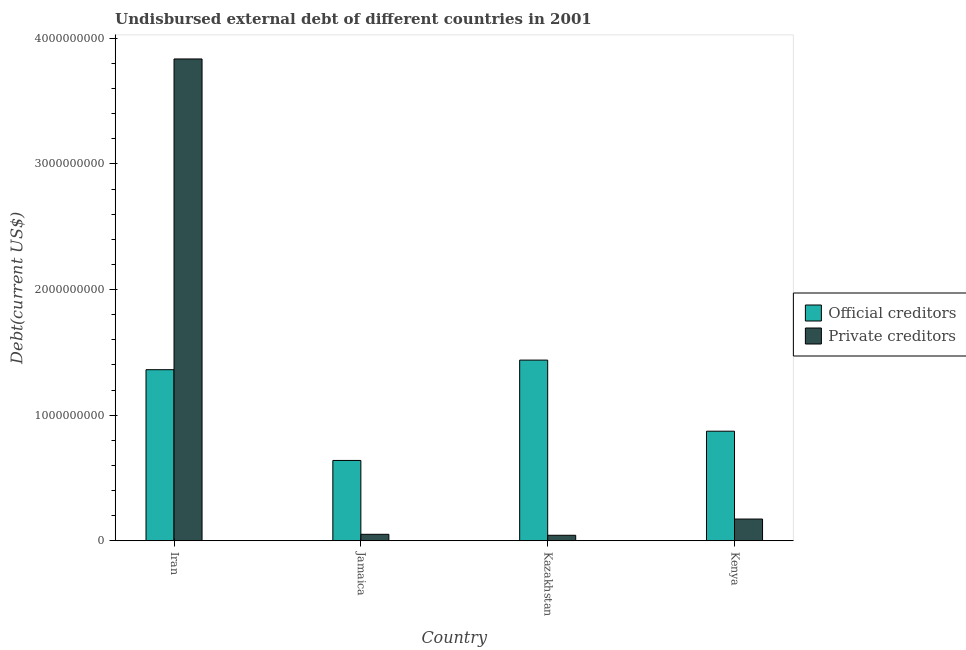How many bars are there on the 4th tick from the left?
Provide a short and direct response. 2. What is the label of the 3rd group of bars from the left?
Your response must be concise. Kazakhstan. In how many cases, is the number of bars for a given country not equal to the number of legend labels?
Offer a terse response. 0. What is the undisbursed external debt of official creditors in Kazakhstan?
Offer a very short reply. 1.44e+09. Across all countries, what is the maximum undisbursed external debt of private creditors?
Offer a very short reply. 3.84e+09. Across all countries, what is the minimum undisbursed external debt of official creditors?
Make the answer very short. 6.39e+08. In which country was the undisbursed external debt of private creditors maximum?
Give a very brief answer. Iran. In which country was the undisbursed external debt of official creditors minimum?
Offer a terse response. Jamaica. What is the total undisbursed external debt of private creditors in the graph?
Give a very brief answer. 4.10e+09. What is the difference between the undisbursed external debt of official creditors in Jamaica and that in Kenya?
Offer a very short reply. -2.33e+08. What is the difference between the undisbursed external debt of official creditors in Kazakhstan and the undisbursed external debt of private creditors in Jamaica?
Your answer should be compact. 1.39e+09. What is the average undisbursed external debt of official creditors per country?
Make the answer very short. 1.08e+09. What is the difference between the undisbursed external debt of private creditors and undisbursed external debt of official creditors in Jamaica?
Your answer should be compact. -5.88e+08. In how many countries, is the undisbursed external debt of private creditors greater than 1800000000 US$?
Your answer should be very brief. 1. What is the ratio of the undisbursed external debt of official creditors in Jamaica to that in Kazakhstan?
Ensure brevity in your answer.  0.44. Is the undisbursed external debt of private creditors in Iran less than that in Kenya?
Your answer should be compact. No. What is the difference between the highest and the second highest undisbursed external debt of private creditors?
Offer a very short reply. 3.66e+09. What is the difference between the highest and the lowest undisbursed external debt of official creditors?
Offer a terse response. 7.99e+08. In how many countries, is the undisbursed external debt of private creditors greater than the average undisbursed external debt of private creditors taken over all countries?
Offer a very short reply. 1. What does the 1st bar from the left in Kazakhstan represents?
Provide a short and direct response. Official creditors. What does the 2nd bar from the right in Jamaica represents?
Your response must be concise. Official creditors. Are all the bars in the graph horizontal?
Provide a succinct answer. No. Are the values on the major ticks of Y-axis written in scientific E-notation?
Your answer should be very brief. No. Does the graph contain any zero values?
Ensure brevity in your answer.  No. How many legend labels are there?
Your answer should be compact. 2. How are the legend labels stacked?
Your answer should be very brief. Vertical. What is the title of the graph?
Your answer should be very brief. Undisbursed external debt of different countries in 2001. Does "Commercial service imports" appear as one of the legend labels in the graph?
Your answer should be very brief. No. What is the label or title of the Y-axis?
Your answer should be compact. Debt(current US$). What is the Debt(current US$) in Official creditors in Iran?
Your answer should be very brief. 1.36e+09. What is the Debt(current US$) in Private creditors in Iran?
Offer a very short reply. 3.84e+09. What is the Debt(current US$) in Official creditors in Jamaica?
Your answer should be very brief. 6.39e+08. What is the Debt(current US$) in Private creditors in Jamaica?
Provide a short and direct response. 5.11e+07. What is the Debt(current US$) in Official creditors in Kazakhstan?
Provide a short and direct response. 1.44e+09. What is the Debt(current US$) in Private creditors in Kazakhstan?
Make the answer very short. 4.34e+07. What is the Debt(current US$) of Official creditors in Kenya?
Give a very brief answer. 8.72e+08. What is the Debt(current US$) of Private creditors in Kenya?
Your answer should be compact. 1.73e+08. Across all countries, what is the maximum Debt(current US$) of Official creditors?
Offer a very short reply. 1.44e+09. Across all countries, what is the maximum Debt(current US$) in Private creditors?
Keep it short and to the point. 3.84e+09. Across all countries, what is the minimum Debt(current US$) in Official creditors?
Offer a very short reply. 6.39e+08. Across all countries, what is the minimum Debt(current US$) in Private creditors?
Offer a very short reply. 4.34e+07. What is the total Debt(current US$) in Official creditors in the graph?
Provide a succinct answer. 4.31e+09. What is the total Debt(current US$) of Private creditors in the graph?
Provide a short and direct response. 4.10e+09. What is the difference between the Debt(current US$) in Official creditors in Iran and that in Jamaica?
Provide a succinct answer. 7.23e+08. What is the difference between the Debt(current US$) of Private creditors in Iran and that in Jamaica?
Your answer should be compact. 3.79e+09. What is the difference between the Debt(current US$) of Official creditors in Iran and that in Kazakhstan?
Make the answer very short. -7.63e+07. What is the difference between the Debt(current US$) in Private creditors in Iran and that in Kazakhstan?
Your answer should be very brief. 3.79e+09. What is the difference between the Debt(current US$) in Official creditors in Iran and that in Kenya?
Your answer should be very brief. 4.90e+08. What is the difference between the Debt(current US$) in Private creditors in Iran and that in Kenya?
Provide a short and direct response. 3.66e+09. What is the difference between the Debt(current US$) in Official creditors in Jamaica and that in Kazakhstan?
Provide a short and direct response. -7.99e+08. What is the difference between the Debt(current US$) of Private creditors in Jamaica and that in Kazakhstan?
Ensure brevity in your answer.  7.71e+06. What is the difference between the Debt(current US$) of Official creditors in Jamaica and that in Kenya?
Your response must be concise. -2.33e+08. What is the difference between the Debt(current US$) in Private creditors in Jamaica and that in Kenya?
Provide a short and direct response. -1.22e+08. What is the difference between the Debt(current US$) in Official creditors in Kazakhstan and that in Kenya?
Provide a succinct answer. 5.66e+08. What is the difference between the Debt(current US$) in Private creditors in Kazakhstan and that in Kenya?
Your answer should be very brief. -1.29e+08. What is the difference between the Debt(current US$) in Official creditors in Iran and the Debt(current US$) in Private creditors in Jamaica?
Make the answer very short. 1.31e+09. What is the difference between the Debt(current US$) in Official creditors in Iran and the Debt(current US$) in Private creditors in Kazakhstan?
Your answer should be compact. 1.32e+09. What is the difference between the Debt(current US$) in Official creditors in Iran and the Debt(current US$) in Private creditors in Kenya?
Ensure brevity in your answer.  1.19e+09. What is the difference between the Debt(current US$) of Official creditors in Jamaica and the Debt(current US$) of Private creditors in Kazakhstan?
Your answer should be compact. 5.96e+08. What is the difference between the Debt(current US$) in Official creditors in Jamaica and the Debt(current US$) in Private creditors in Kenya?
Make the answer very short. 4.67e+08. What is the difference between the Debt(current US$) of Official creditors in Kazakhstan and the Debt(current US$) of Private creditors in Kenya?
Your answer should be very brief. 1.27e+09. What is the average Debt(current US$) in Official creditors per country?
Provide a succinct answer. 1.08e+09. What is the average Debt(current US$) in Private creditors per country?
Make the answer very short. 1.03e+09. What is the difference between the Debt(current US$) of Official creditors and Debt(current US$) of Private creditors in Iran?
Provide a succinct answer. -2.47e+09. What is the difference between the Debt(current US$) of Official creditors and Debt(current US$) of Private creditors in Jamaica?
Give a very brief answer. 5.88e+08. What is the difference between the Debt(current US$) in Official creditors and Debt(current US$) in Private creditors in Kazakhstan?
Keep it short and to the point. 1.39e+09. What is the difference between the Debt(current US$) in Official creditors and Debt(current US$) in Private creditors in Kenya?
Ensure brevity in your answer.  7.00e+08. What is the ratio of the Debt(current US$) of Official creditors in Iran to that in Jamaica?
Ensure brevity in your answer.  2.13. What is the ratio of the Debt(current US$) in Private creditors in Iran to that in Jamaica?
Offer a terse response. 75.09. What is the ratio of the Debt(current US$) of Official creditors in Iran to that in Kazakhstan?
Make the answer very short. 0.95. What is the ratio of the Debt(current US$) in Private creditors in Iran to that in Kazakhstan?
Ensure brevity in your answer.  88.42. What is the ratio of the Debt(current US$) of Official creditors in Iran to that in Kenya?
Provide a short and direct response. 1.56. What is the ratio of the Debt(current US$) in Private creditors in Iran to that in Kenya?
Offer a very short reply. 22.22. What is the ratio of the Debt(current US$) of Official creditors in Jamaica to that in Kazakhstan?
Your answer should be compact. 0.44. What is the ratio of the Debt(current US$) in Private creditors in Jamaica to that in Kazakhstan?
Ensure brevity in your answer.  1.18. What is the ratio of the Debt(current US$) in Official creditors in Jamaica to that in Kenya?
Ensure brevity in your answer.  0.73. What is the ratio of the Debt(current US$) of Private creditors in Jamaica to that in Kenya?
Ensure brevity in your answer.  0.3. What is the ratio of the Debt(current US$) in Official creditors in Kazakhstan to that in Kenya?
Provide a succinct answer. 1.65. What is the ratio of the Debt(current US$) of Private creditors in Kazakhstan to that in Kenya?
Offer a very short reply. 0.25. What is the difference between the highest and the second highest Debt(current US$) of Official creditors?
Offer a terse response. 7.63e+07. What is the difference between the highest and the second highest Debt(current US$) of Private creditors?
Your answer should be compact. 3.66e+09. What is the difference between the highest and the lowest Debt(current US$) in Official creditors?
Provide a short and direct response. 7.99e+08. What is the difference between the highest and the lowest Debt(current US$) in Private creditors?
Your response must be concise. 3.79e+09. 